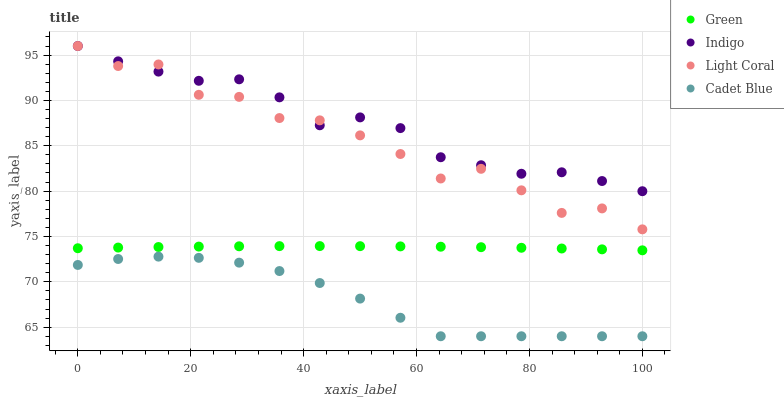Does Cadet Blue have the minimum area under the curve?
Answer yes or no. Yes. Does Indigo have the maximum area under the curve?
Answer yes or no. Yes. Does Indigo have the minimum area under the curve?
Answer yes or no. No. Does Cadet Blue have the maximum area under the curve?
Answer yes or no. No. Is Green the smoothest?
Answer yes or no. Yes. Is Light Coral the roughest?
Answer yes or no. Yes. Is Indigo the smoothest?
Answer yes or no. No. Is Indigo the roughest?
Answer yes or no. No. Does Cadet Blue have the lowest value?
Answer yes or no. Yes. Does Indigo have the lowest value?
Answer yes or no. No. Does Indigo have the highest value?
Answer yes or no. Yes. Does Cadet Blue have the highest value?
Answer yes or no. No. Is Cadet Blue less than Light Coral?
Answer yes or no. Yes. Is Indigo greater than Green?
Answer yes or no. Yes. Does Light Coral intersect Indigo?
Answer yes or no. Yes. Is Light Coral less than Indigo?
Answer yes or no. No. Is Light Coral greater than Indigo?
Answer yes or no. No. Does Cadet Blue intersect Light Coral?
Answer yes or no. No. 